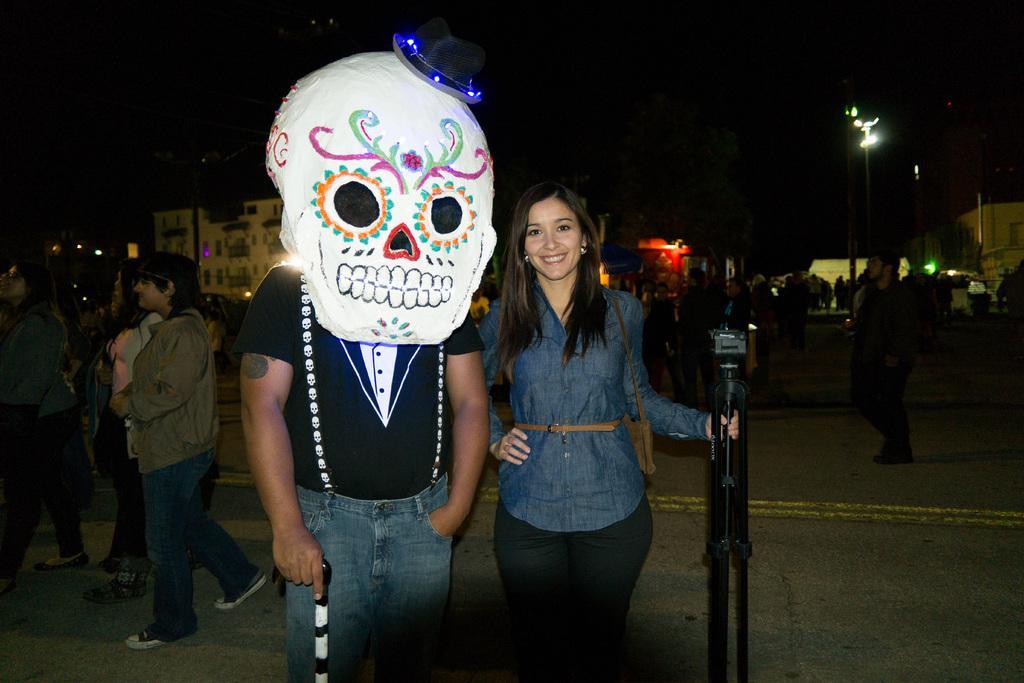Could you give a brief overview of what you see in this image? In the image few people are standing and walking. Behind them there are some buildings and poles and lights. 